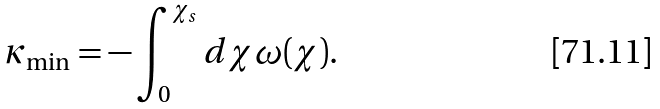<formula> <loc_0><loc_0><loc_500><loc_500>\kappa _ { \min } = - \int _ { 0 } ^ { \chi _ { s } } d \chi \omega ( \chi ) .</formula> 